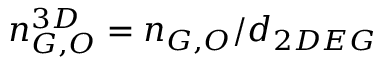Convert formula to latex. <formula><loc_0><loc_0><loc_500><loc_500>n _ { G , O } ^ { 3 D } = n _ { G , O } / d _ { 2 D E G }</formula> 